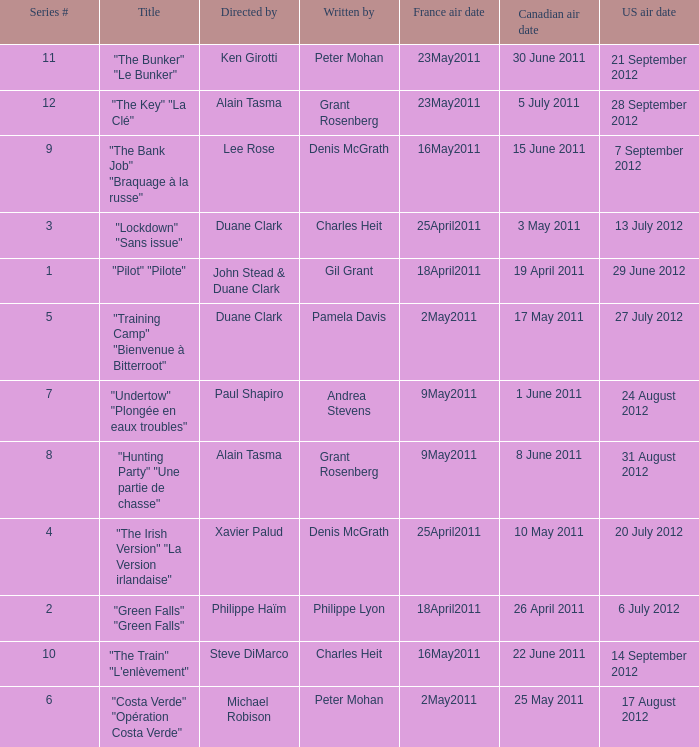What is the US air date when the director is ken girotti? 21 September 2012. 